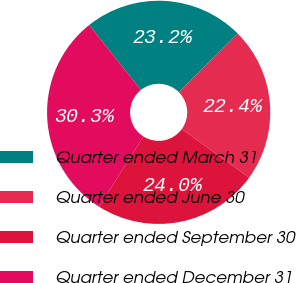Convert chart to OTSL. <chart><loc_0><loc_0><loc_500><loc_500><pie_chart><fcel>Quarter ended March 31<fcel>Quarter ended June 30<fcel>Quarter ended September 30<fcel>Quarter ended December 31<nl><fcel>23.22%<fcel>22.42%<fcel>24.02%<fcel>30.34%<nl></chart> 